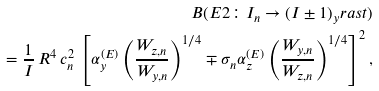<formula> <loc_0><loc_0><loc_500><loc_500>B ( E 2 \colon I _ { n } \rightarrow ( I \pm 1 ) _ { y } r a s t ) \\ = \frac { 1 } { I } \, R ^ { 4 } \, c _ { n } ^ { 2 } \, \left [ \alpha _ { y } ^ { ( E ) } \left ( \frac { W _ { z , n } } { W _ { y , n } } \right ) ^ { 1 / 4 } \mp \sigma _ { n } \alpha _ { z } ^ { ( E ) } \left ( \frac { W _ { y , n } } { W _ { z , n } } \right ) ^ { 1 / 4 } \right ] ^ { 2 } ,</formula> 